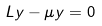Convert formula to latex. <formula><loc_0><loc_0><loc_500><loc_500>L y - \mu y = 0</formula> 